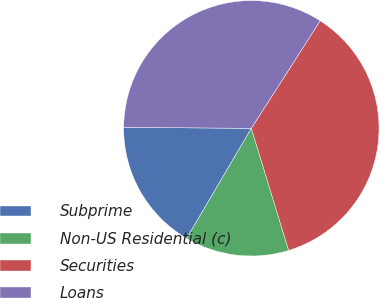Convert chart. <chart><loc_0><loc_0><loc_500><loc_500><pie_chart><fcel>Subprime<fcel>Non-US Residential (c)<fcel>Securities<fcel>Loans<nl><fcel>16.66%<fcel>13.18%<fcel>36.21%<fcel>33.95%<nl></chart> 